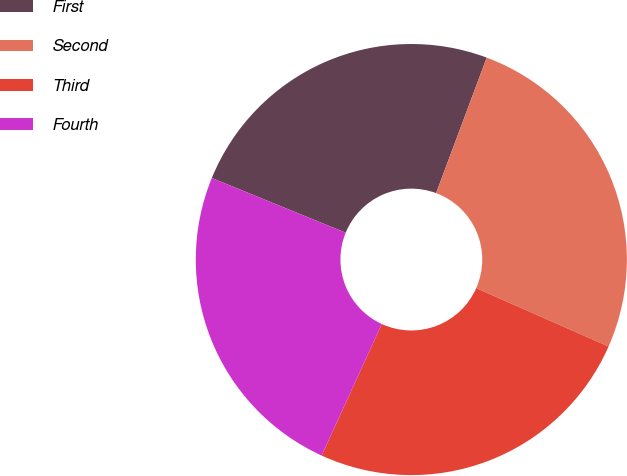Convert chart to OTSL. <chart><loc_0><loc_0><loc_500><loc_500><pie_chart><fcel>First<fcel>Second<fcel>Third<fcel>Fourth<nl><fcel>24.51%<fcel>25.92%<fcel>25.22%<fcel>24.34%<nl></chart> 